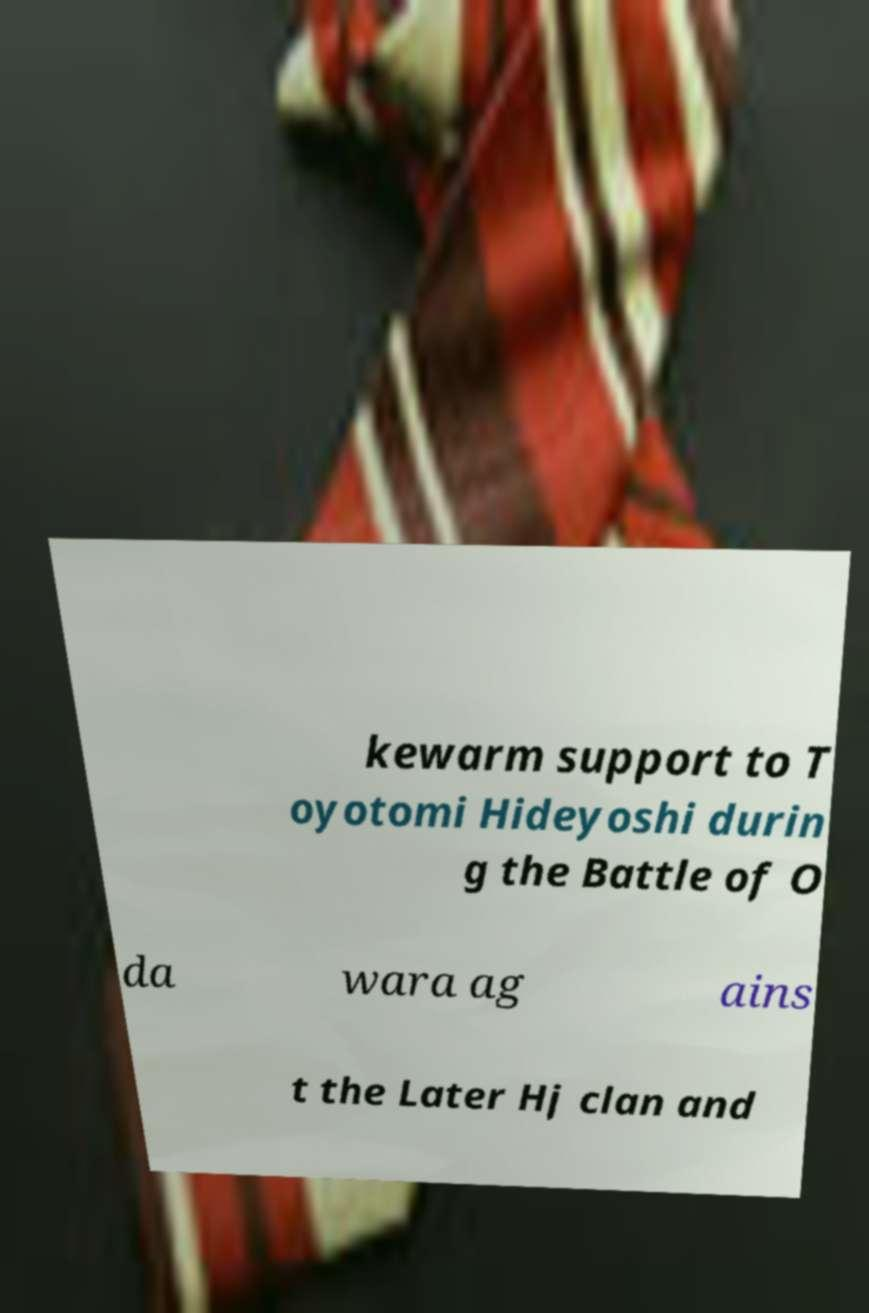Could you assist in decoding the text presented in this image and type it out clearly? kewarm support to T oyotomi Hideyoshi durin g the Battle of O da wara ag ains t the Later Hj clan and 